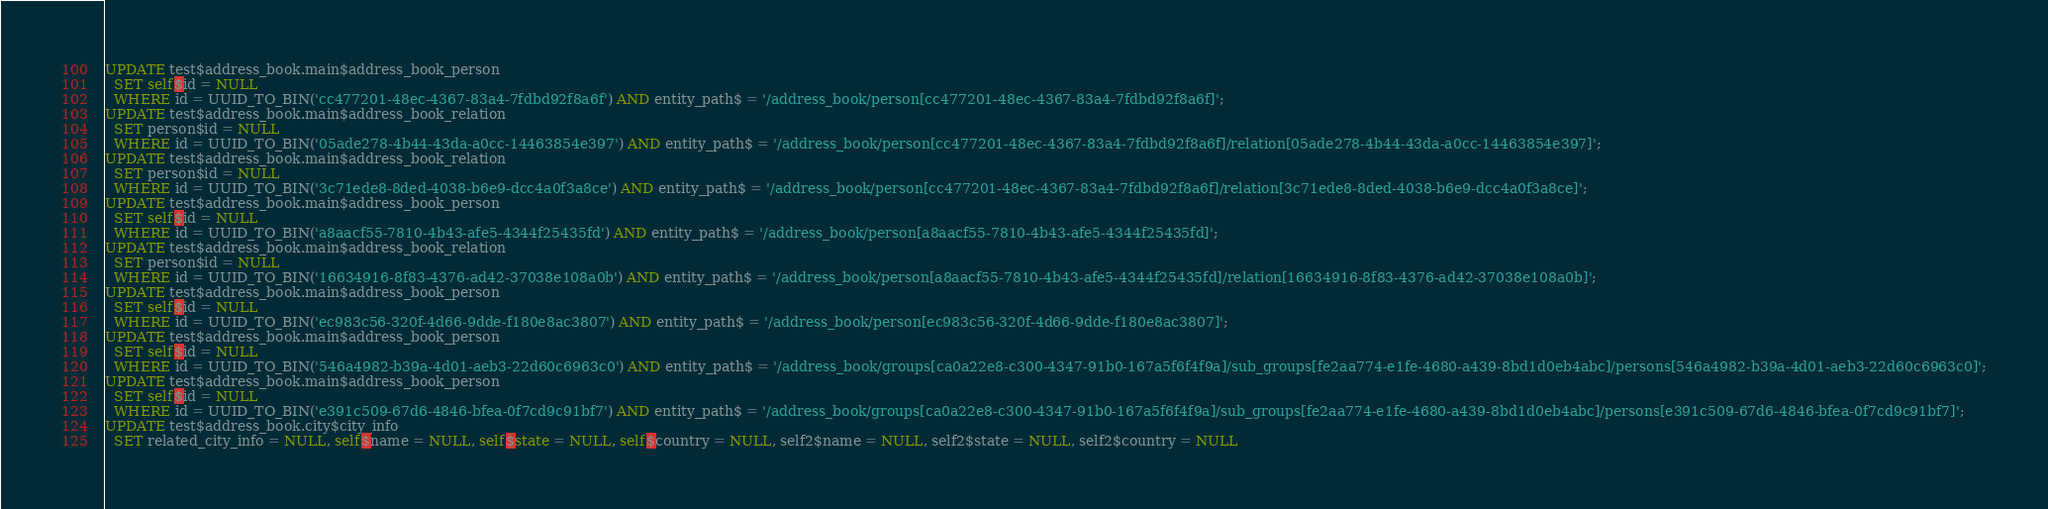Convert code to text. <code><loc_0><loc_0><loc_500><loc_500><_SQL_>UPDATE test$address_book.main$address_book_person
  SET self$id = NULL
  WHERE id = UUID_TO_BIN('cc477201-48ec-4367-83a4-7fdbd92f8a6f') AND entity_path$ = '/address_book/person[cc477201-48ec-4367-83a4-7fdbd92f8a6f]';
UPDATE test$address_book.main$address_book_relation
  SET person$id = NULL
  WHERE id = UUID_TO_BIN('05ade278-4b44-43da-a0cc-14463854e397') AND entity_path$ = '/address_book/person[cc477201-48ec-4367-83a4-7fdbd92f8a6f]/relation[05ade278-4b44-43da-a0cc-14463854e397]';
UPDATE test$address_book.main$address_book_relation
  SET person$id = NULL
  WHERE id = UUID_TO_BIN('3c71ede8-8ded-4038-b6e9-dcc4a0f3a8ce') AND entity_path$ = '/address_book/person[cc477201-48ec-4367-83a4-7fdbd92f8a6f]/relation[3c71ede8-8ded-4038-b6e9-dcc4a0f3a8ce]';
UPDATE test$address_book.main$address_book_person
  SET self$id = NULL
  WHERE id = UUID_TO_BIN('a8aacf55-7810-4b43-afe5-4344f25435fd') AND entity_path$ = '/address_book/person[a8aacf55-7810-4b43-afe5-4344f25435fd]';
UPDATE test$address_book.main$address_book_relation
  SET person$id = NULL
  WHERE id = UUID_TO_BIN('16634916-8f83-4376-ad42-37038e108a0b') AND entity_path$ = '/address_book/person[a8aacf55-7810-4b43-afe5-4344f25435fd]/relation[16634916-8f83-4376-ad42-37038e108a0b]';
UPDATE test$address_book.main$address_book_person
  SET self$id = NULL
  WHERE id = UUID_TO_BIN('ec983c56-320f-4d66-9dde-f180e8ac3807') AND entity_path$ = '/address_book/person[ec983c56-320f-4d66-9dde-f180e8ac3807]';
UPDATE test$address_book.main$address_book_person
  SET self$id = NULL
  WHERE id = UUID_TO_BIN('546a4982-b39a-4d01-aeb3-22d60c6963c0') AND entity_path$ = '/address_book/groups[ca0a22e8-c300-4347-91b0-167a5f6f4f9a]/sub_groups[fe2aa774-e1fe-4680-a439-8bd1d0eb4abc]/persons[546a4982-b39a-4d01-aeb3-22d60c6963c0]';
UPDATE test$address_book.main$address_book_person
  SET self$id = NULL
  WHERE id = UUID_TO_BIN('e391c509-67d6-4846-bfea-0f7cd9c91bf7') AND entity_path$ = '/address_book/groups[ca0a22e8-c300-4347-91b0-167a5f6f4f9a]/sub_groups[fe2aa774-e1fe-4680-a439-8bd1d0eb4abc]/persons[e391c509-67d6-4846-bfea-0f7cd9c91bf7]';
UPDATE test$address_book.city$city_info
  SET related_city_info = NULL, self$name = NULL, self$state = NULL, self$country = NULL, self2$name = NULL, self2$state = NULL, self2$country = NULL</code> 